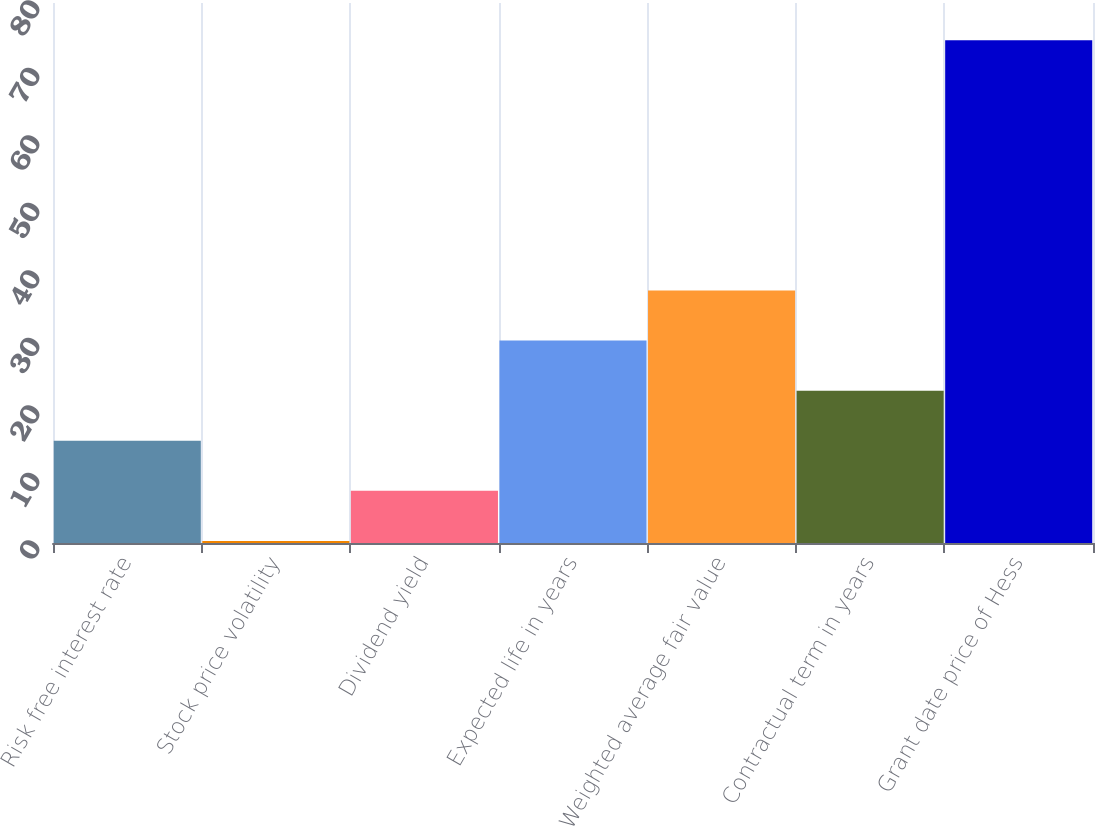Convert chart to OTSL. <chart><loc_0><loc_0><loc_500><loc_500><bar_chart><fcel>Risk free interest rate<fcel>Stock price volatility<fcel>Dividend yield<fcel>Expected life in years<fcel>Weighted average fair value<fcel>Contractual term in years<fcel>Grant date price of Hess<nl><fcel>15.15<fcel>0.31<fcel>7.73<fcel>29.99<fcel>37.41<fcel>22.57<fcel>74.49<nl></chart> 